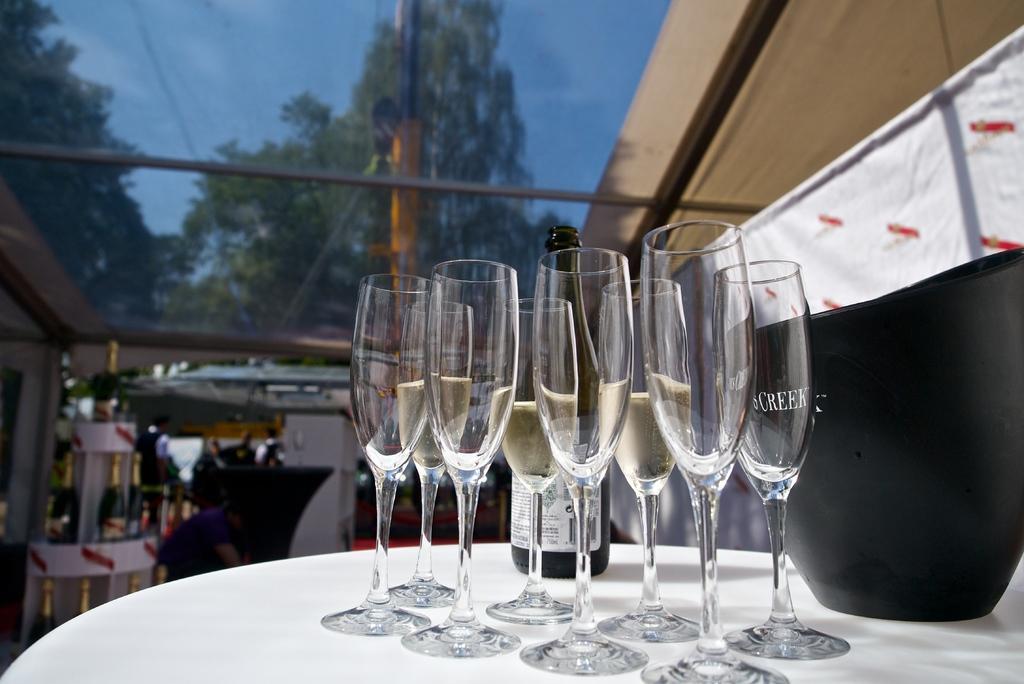Could you give a brief overview of what you see in this image? On the right side, there are glasses, a bottle and a black color object placed on a white color table. In the background, there are trees, a building, clouds in the blue sky and other objects. 